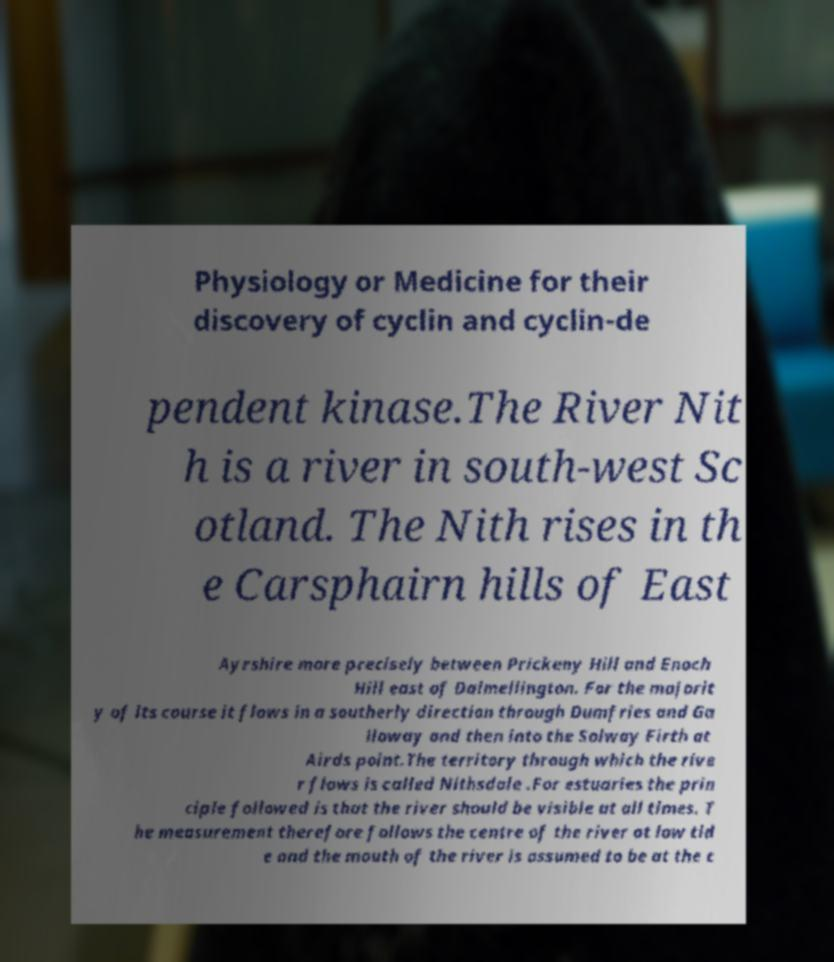Could you assist in decoding the text presented in this image and type it out clearly? Physiology or Medicine for their discovery of cyclin and cyclin-de pendent kinase.The River Nit h is a river in south-west Sc otland. The Nith rises in th e Carsphairn hills of East Ayrshire more precisely between Prickeny Hill and Enoch Hill east of Dalmellington. For the majorit y of its course it flows in a southerly direction through Dumfries and Ga lloway and then into the Solway Firth at Airds point.The territory through which the rive r flows is called Nithsdale .For estuaries the prin ciple followed is that the river should be visible at all times. T he measurement therefore follows the centre of the river at low tid e and the mouth of the river is assumed to be at the c 